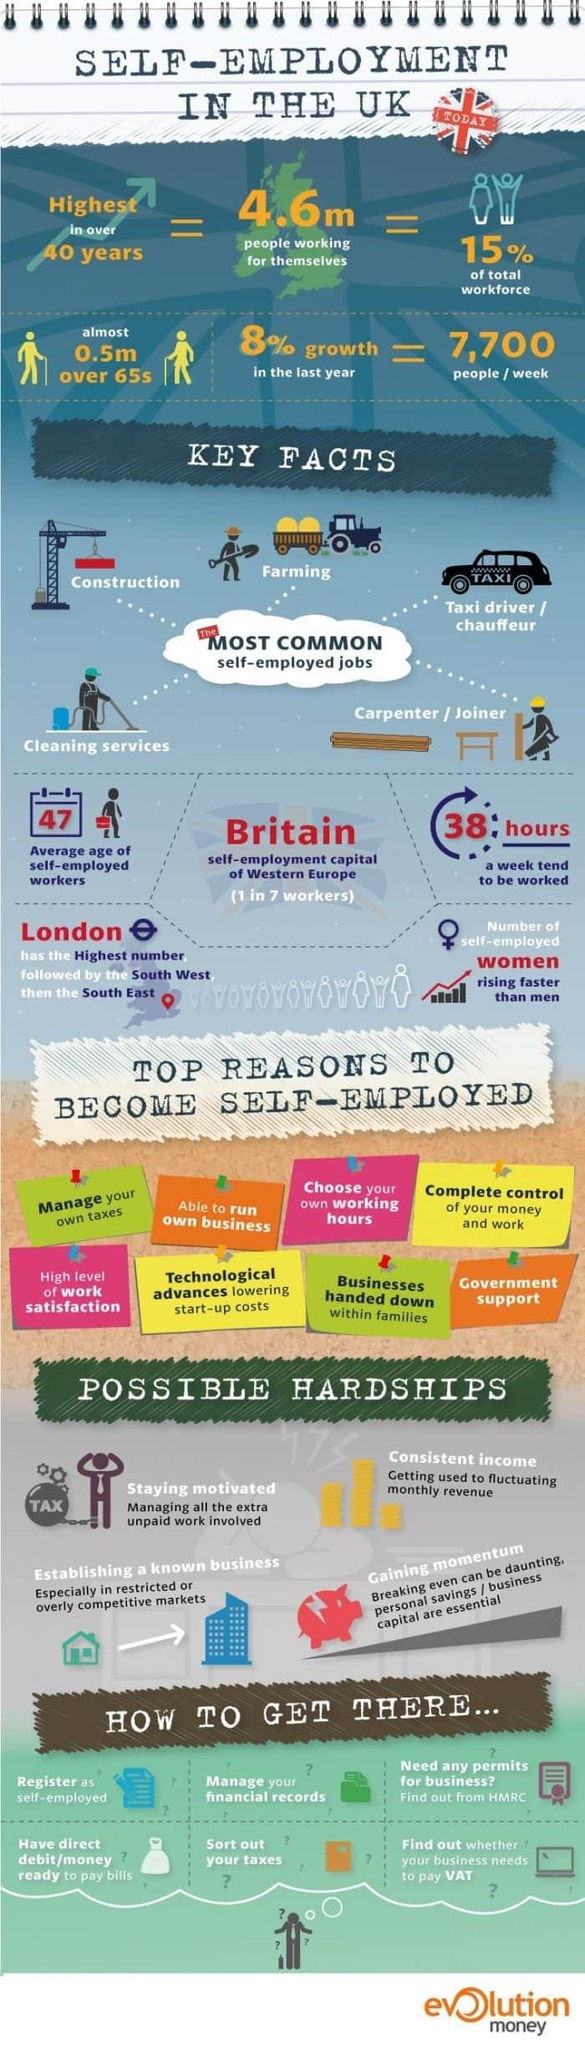Specify some key components in this picture. The South West of the United Kingdom has the second highest number of self-employed individuals in the country. There are 5 commonly listed types of self-employed jobs. According to the data, the South East region of the United Kingdom has the third highest number of self-employed workers. 